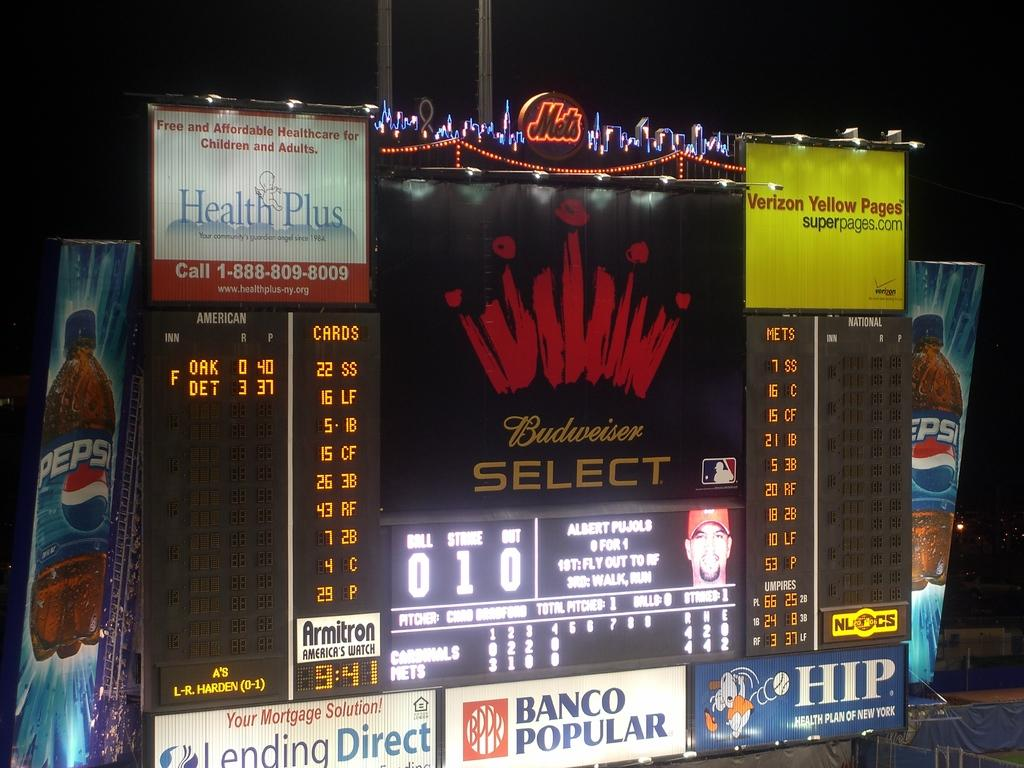Provide a one-sentence caption for the provided image. Score board featuring Budweiser Select, Lending Direct, Pepsi Verizon Yellow Pages, and HIP. 